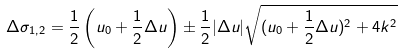Convert formula to latex. <formula><loc_0><loc_0><loc_500><loc_500>\Delta \sigma _ { 1 , 2 } = \frac { 1 } { 2 } \left ( u _ { 0 } + \frac { 1 } { 2 } \Delta u \right ) \pm \frac { 1 } { 2 } | \Delta u | \sqrt { ( u _ { 0 } + \frac { 1 } { 2 } \Delta u ) ^ { 2 } + 4 k ^ { 2 } }</formula> 